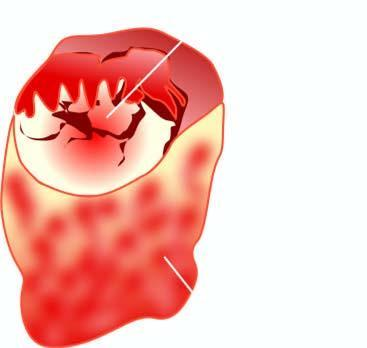what shows a single nodule separated from the rest of thyroid parenchyma by incomplete fibrous septa?
Answer the question using a single word or phrase. Cut surface of the enlarged thyroid gland 